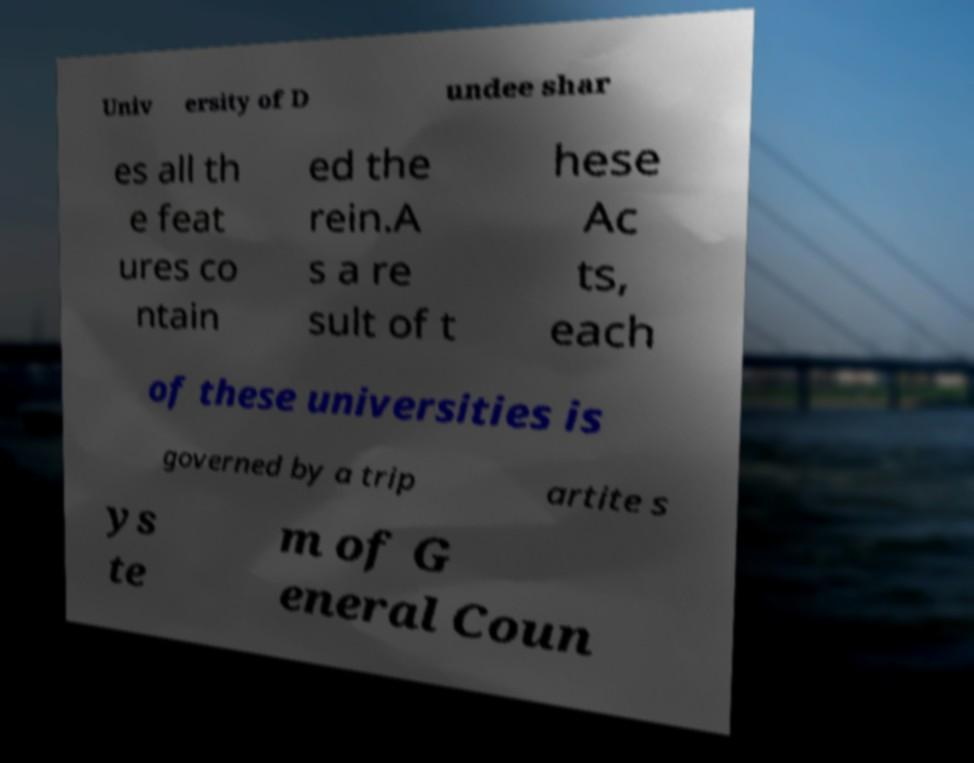Can you accurately transcribe the text from the provided image for me? Univ ersity of D undee shar es all th e feat ures co ntain ed the rein.A s a re sult of t hese Ac ts, each of these universities is governed by a trip artite s ys te m of G eneral Coun 